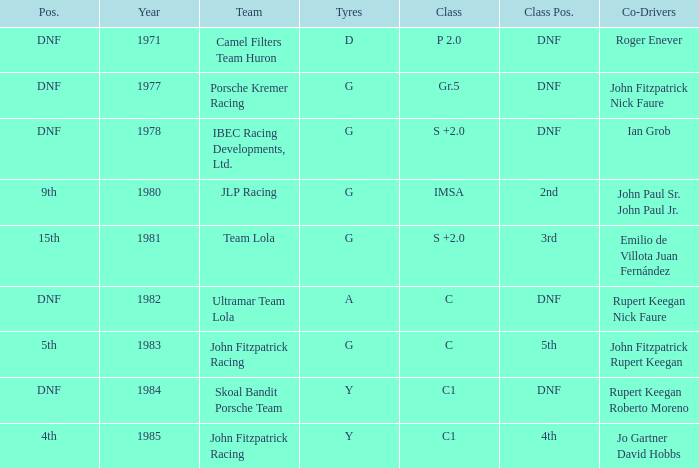Which tires were in Class C in years before 1983? A. 